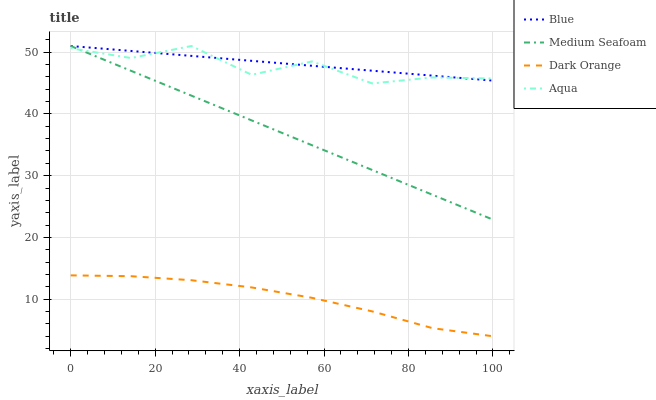Does Dark Orange have the minimum area under the curve?
Answer yes or no. Yes. Does Blue have the maximum area under the curve?
Answer yes or no. Yes. Does Aqua have the minimum area under the curve?
Answer yes or no. No. Does Aqua have the maximum area under the curve?
Answer yes or no. No. Is Blue the smoothest?
Answer yes or no. Yes. Is Aqua the roughest?
Answer yes or no. Yes. Is Dark Orange the smoothest?
Answer yes or no. No. Is Dark Orange the roughest?
Answer yes or no. No. Does Dark Orange have the lowest value?
Answer yes or no. Yes. Does Aqua have the lowest value?
Answer yes or no. No. Does Medium Seafoam have the highest value?
Answer yes or no. Yes. Does Dark Orange have the highest value?
Answer yes or no. No. Is Dark Orange less than Medium Seafoam?
Answer yes or no. Yes. Is Blue greater than Dark Orange?
Answer yes or no. Yes. Does Blue intersect Aqua?
Answer yes or no. Yes. Is Blue less than Aqua?
Answer yes or no. No. Is Blue greater than Aqua?
Answer yes or no. No. Does Dark Orange intersect Medium Seafoam?
Answer yes or no. No. 